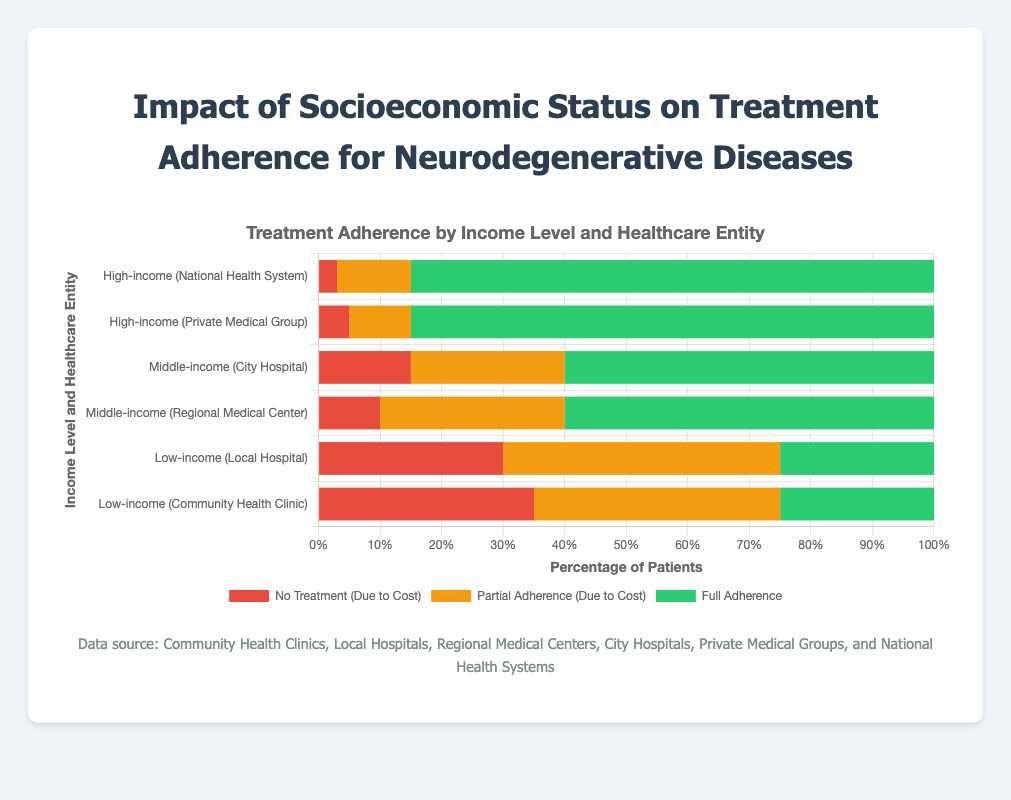What is the impact of socioeconomic status on full adherence to treatment? By observing the lengths of the green bars for each income level, we see that high-income groups have the highest full adherence rates (85%), followed by middle-income groups (60%), and low-income groups (25%).
Answer: High-income (85%), Middle-income (60%), Low-income (25%) Which entity has the highest rate of no treatment due to cost among low-income groups? Among low-income entities, visually comparing the length of the red bars shows that Community Health Clinic has a higher rate of no treatment due to cost (35%) compared to Local Hospital (30%).
Answer: Community Health Clinic (35%) How does the rate of partial adherence due to cost compare between middle-income and high-income groups? Comparing the lengths of the orange bars, middle-income entities (30% and 25%) have higher partial adherence rates than high-income entities (12% and 10%).
Answer: Middle-income (30% and 25%) > High-income (12% and 10%) What percentage of patients from community health clinics have either no treatment or partial adherence due to cost? Adding the no treatment (35%) and partial adherence (40%) rates for Community Health Clinic, we get 35% + 40% = 75%.
Answer: 75% Which income level shows the lowest percentage of no treatment due to cost, and what is that percentage? By scanning the red bars, the high-income entities have the lowest percentage of no treatment due to cost (Private Medical Group 5% and National Health System 3%).
Answer: High-income (3%) What is the difference in full adherence rates between middle-income and low-income groups? The full adherence rate for middle-income is 60% and for low-income is 25%. The difference is 60% - 25% = 35%.
Answer: 35% Compare the percentage of patients with partial adherence due to cost between Local Hospital and City Hospital. The partial adherence rate for Local Hospital (low-income) is 45%, compared to City Hospital (middle-income) which is 25%.
Answer: Local Hospital (45%) > City Hospital (25%) What can be inferred about the treatment adherence of patients in private versus public institutions for the high-income group? Both National Health System (public) and Private Medical Group have very similar rates of full adherence (85%) and partial adherence (12% and 10%), indicating good adherence in high-income groups regardless of the type of healthcare provider.
Answer: Similar adherence rates Which healthcare entity shows the highest full adherence rate among middle-income groups? Both Regional Medical Center and City Hospital have the same full adherence rate of 60%, which is the highest among middle-income groups.
Answer: Both Regional Medical Center and City Hospital (60%) 